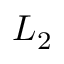Convert formula to latex. <formula><loc_0><loc_0><loc_500><loc_500>L _ { 2 }</formula> 